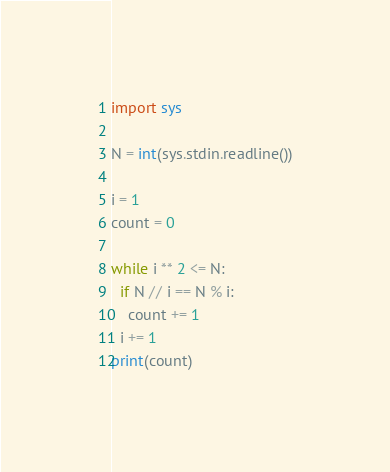Convert code to text. <code><loc_0><loc_0><loc_500><loc_500><_Python_>import sys

N = int(sys.stdin.readline())

i = 1
count = 0

while i ** 2 <= N:
  if N // i == N % i:
    count += 1
  i += 1
print(count)</code> 